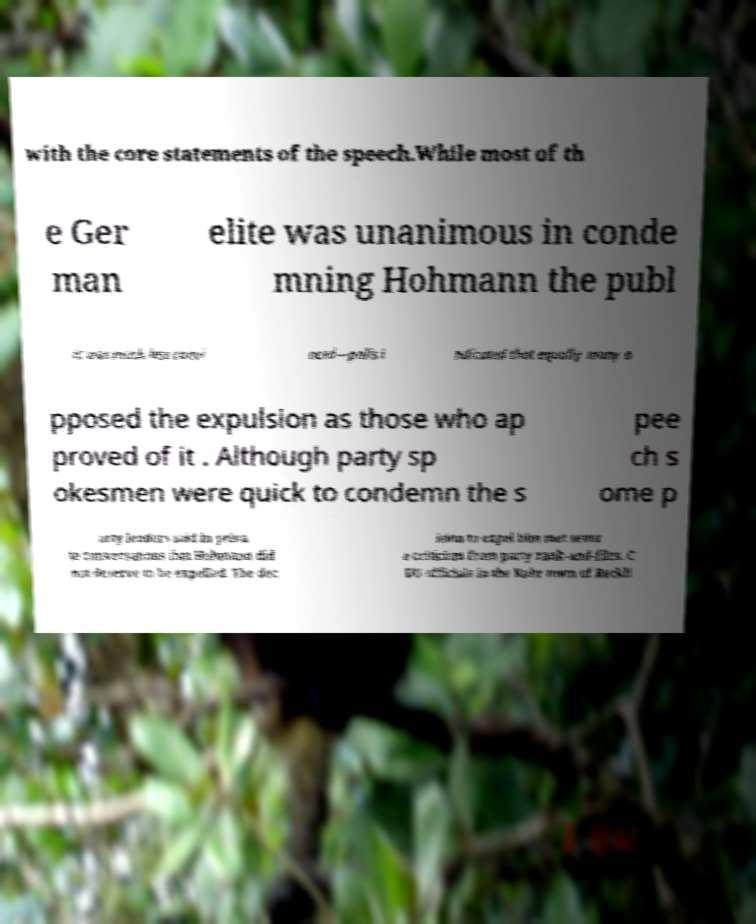What messages or text are displayed in this image? I need them in a readable, typed format. with the core statements of the speech.While most of th e Ger man elite was unanimous in conde mning Hohmann the publ ic was much less convi nced—polls i ndicated that equally many o pposed the expulsion as those who ap proved of it . Although party sp okesmen were quick to condemn the s pee ch s ome p arty leaders said in priva te conversations that Hohmann did not deserve to be expelled. The dec ision to expel him met sever e criticism from party rank-and-files. C DU officials in the Ruhr town of Reckli 